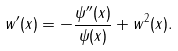Convert formula to latex. <formula><loc_0><loc_0><loc_500><loc_500>w ^ { \prime } ( x ) = - \frac { \psi ^ { \prime \prime } ( x ) } { \psi ( x ) } + w ^ { 2 } ( x ) .</formula> 